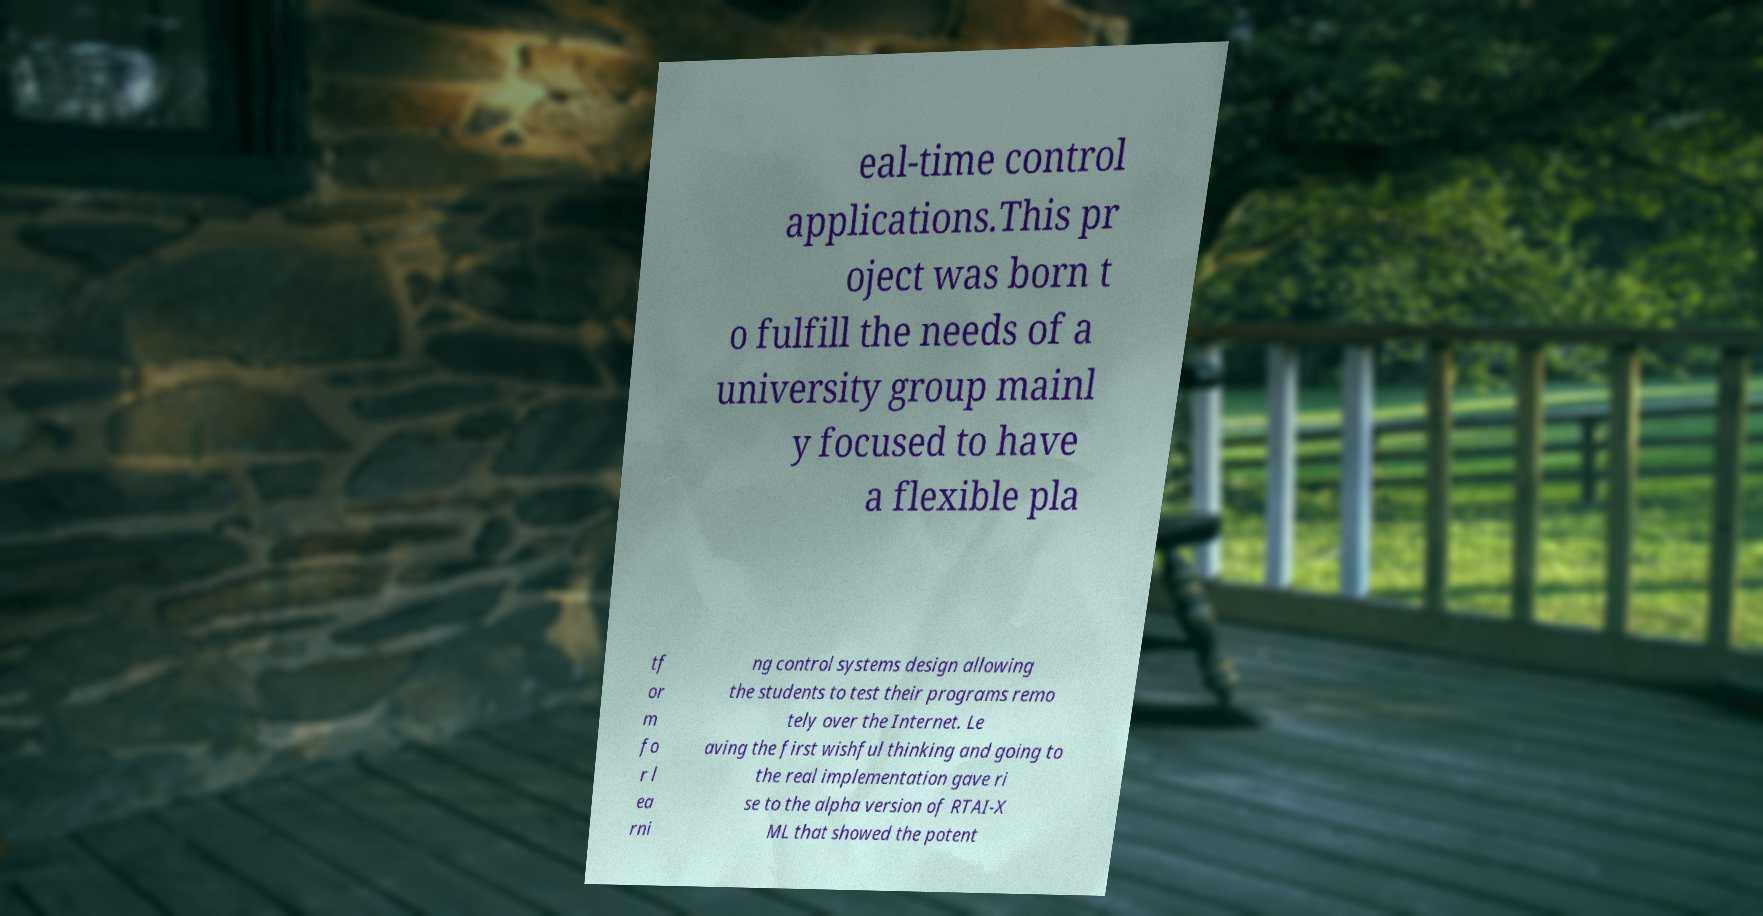I need the written content from this picture converted into text. Can you do that? eal-time control applications.This pr oject was born t o fulfill the needs of a university group mainl y focused to have a flexible pla tf or m fo r l ea rni ng control systems design allowing the students to test their programs remo tely over the Internet. Le aving the first wishful thinking and going to the real implementation gave ri se to the alpha version of RTAI-X ML that showed the potent 